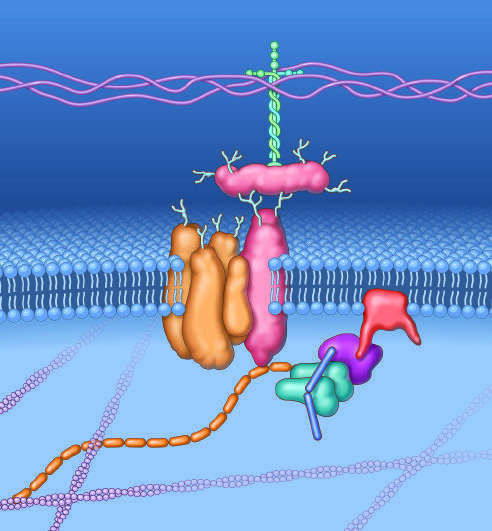does the light green polypeptides serve to couple the cell membrane to extracellular matrix proteins such as laminin-2 and the intracellular cytoskeleton?
Answer the question using a single word or phrase. No 